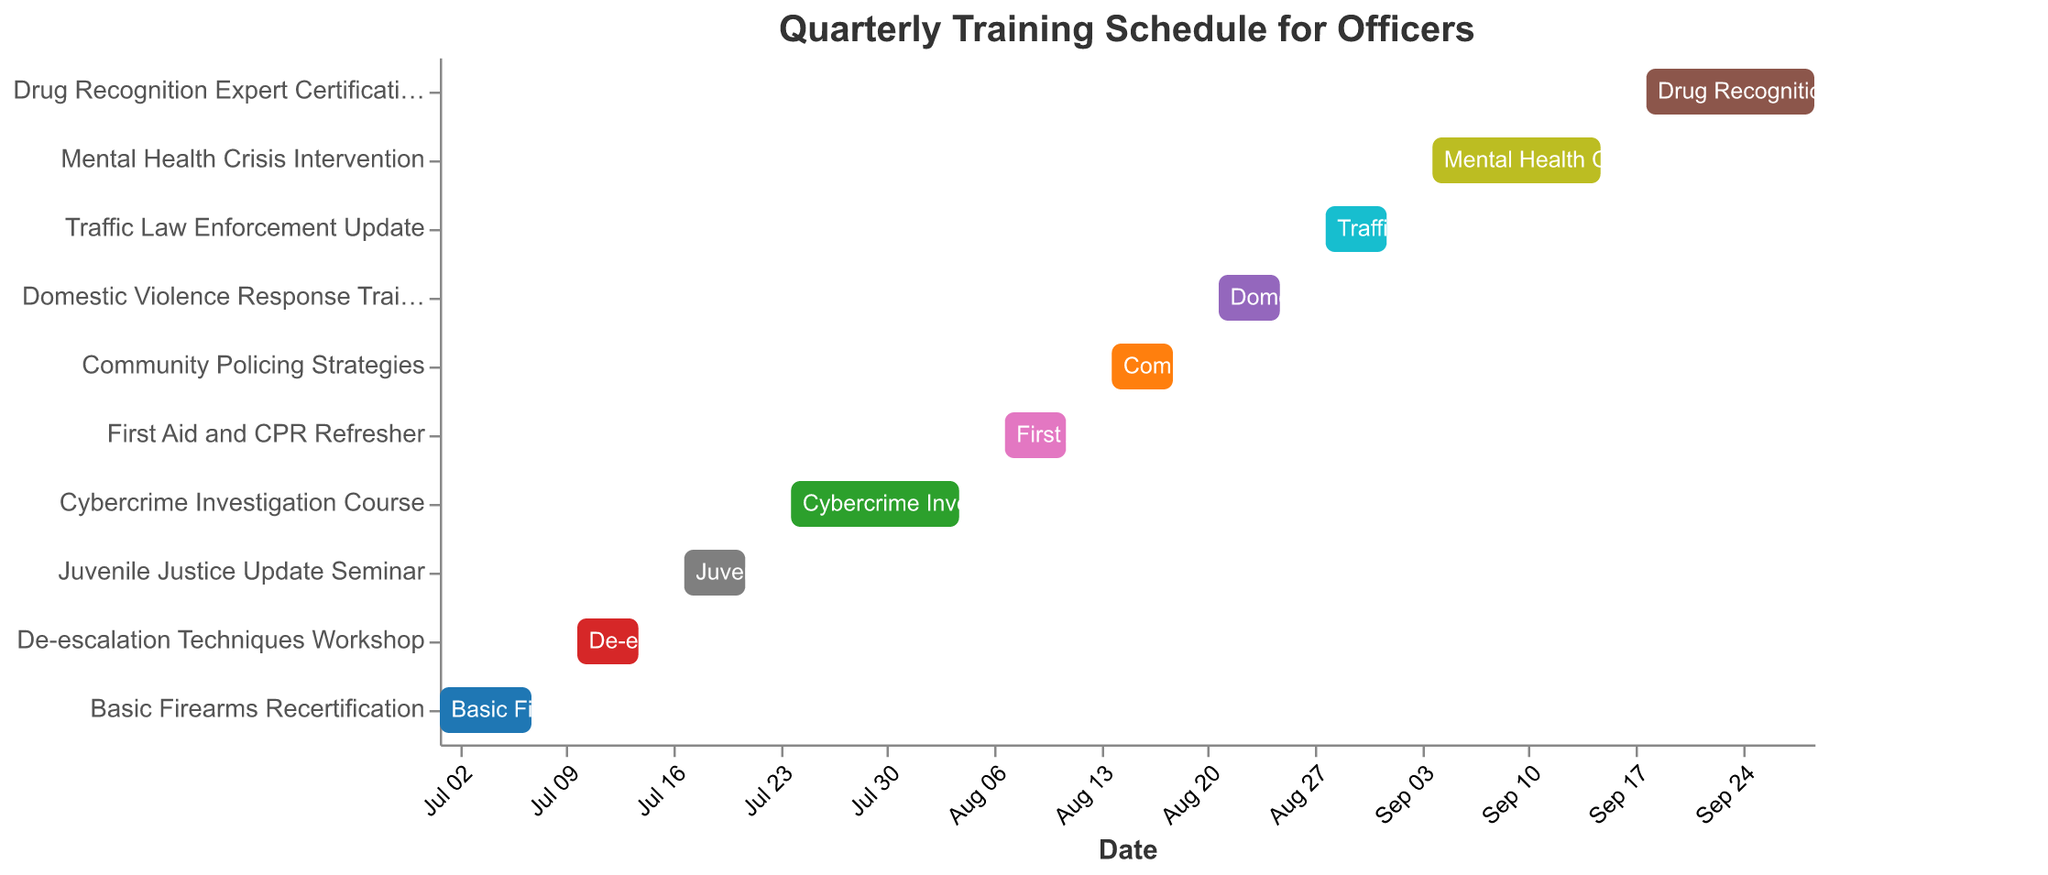What is the title of the chart? The title of the chart is generally displayed at the top of the figure. In this case, it is labeled as "Quarterly Training Schedule for Officers."
Answer: Quarterly Training Schedule for Officers How many training sessions are scheduled in total? By counting the individual bars representing each training session listed on the chart, we can determine the total number of sessions.
Answer: 10 Which training session starts on August 14, 2023? By looking at the timeline on the Gantt chart, identify the task bar that starts on August 14, 2023, which is "Community Policing Strategies."
Answer: Community Policing Strategies What is the duration of the "Cybercrime Investigation Course"? Find the start and end dates for "Cybercrime Investigation Course" on the chart (July 24 to August 04) and calculate the number of days between these dates.
Answer: 12 days Which training session lasts the longest? Compare the duration of all tasks by looking at the length of the bars representing each training session. "Mental Health Crisis Intervention" and "Drug Recognition Expert Certification" both last 12 days, but starting on different dates. Check either task for duration confirmation.
Answer: Cybercrime Investigation Course How many training sessions are scheduled in July? By checking the start and end dates of each task and counting those that fall within July, we find the number of sessions scheduled. There are four: Basic Firearms Recertification, De-escalation Techniques Workshop, Juvenile Justice Update Seminar, Cybercrime Investigation Course (partially).
Answer: 4 During which date range is the "Domestic Violence Response Training" scheduled? Refer to the bar labeled as "Domestic Violence Response Training" on the y-axis, and note its corresponding start and end dates on the x-axis.
Answer: August 21 to August 25, 2023 Which courses overlap within the schedule? To identify overlapping courses, visually inspect the timeline to see which bars span the same dates. The "Cybercrime Investigation Course" (July 24 - August 04) overlaps with "First Aid and CPR Refresher" (August 07 - August 11).
Answer: None Between "Traffic Law Enforcement Update" and "Mental Health Crisis Intervention," which one starts later? Compare the start dates of "Traffic Law Enforcement Update" (August 28) and "Mental Health Crisis Intervention" (September 04) by looking at where their bars begin on the x-axis.
Answer: Mental Health Crisis Intervention Is there any training session that spans across two months? Identify any bars that start in one month and end in another. The "Cybercrime Investigation Course" starts in July and ends in August.
Answer: Cybercrime Investigation Course 